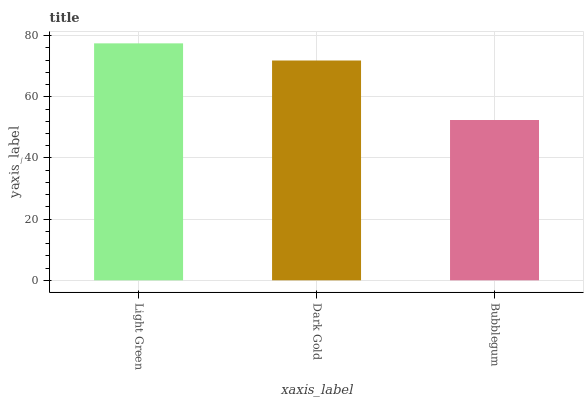Is Dark Gold the minimum?
Answer yes or no. No. Is Dark Gold the maximum?
Answer yes or no. No. Is Light Green greater than Dark Gold?
Answer yes or no. Yes. Is Dark Gold less than Light Green?
Answer yes or no. Yes. Is Dark Gold greater than Light Green?
Answer yes or no. No. Is Light Green less than Dark Gold?
Answer yes or no. No. Is Dark Gold the high median?
Answer yes or no. Yes. Is Dark Gold the low median?
Answer yes or no. Yes. Is Bubblegum the high median?
Answer yes or no. No. Is Bubblegum the low median?
Answer yes or no. No. 